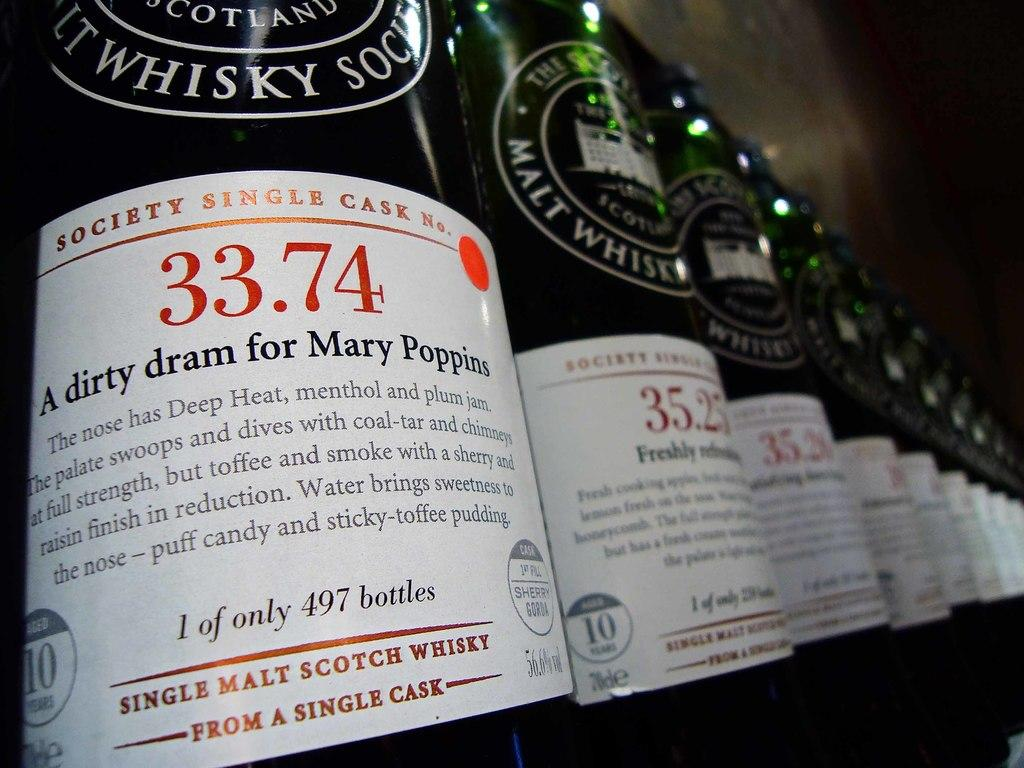<image>
Relay a brief, clear account of the picture shown. Green bottles in a row with white labels that say 1 of only 497 bottles. 